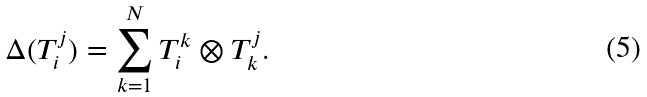Convert formula to latex. <formula><loc_0><loc_0><loc_500><loc_500>\Delta ( T _ { i } ^ { j } ) = \sum _ { k = 1 } ^ { N } T _ { i } ^ { k } \otimes T _ { k } ^ { j } .</formula> 